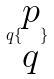<formula> <loc_0><loc_0><loc_500><loc_500>q \{ \begin{matrix} p \\ q \end{matrix} \}</formula> 